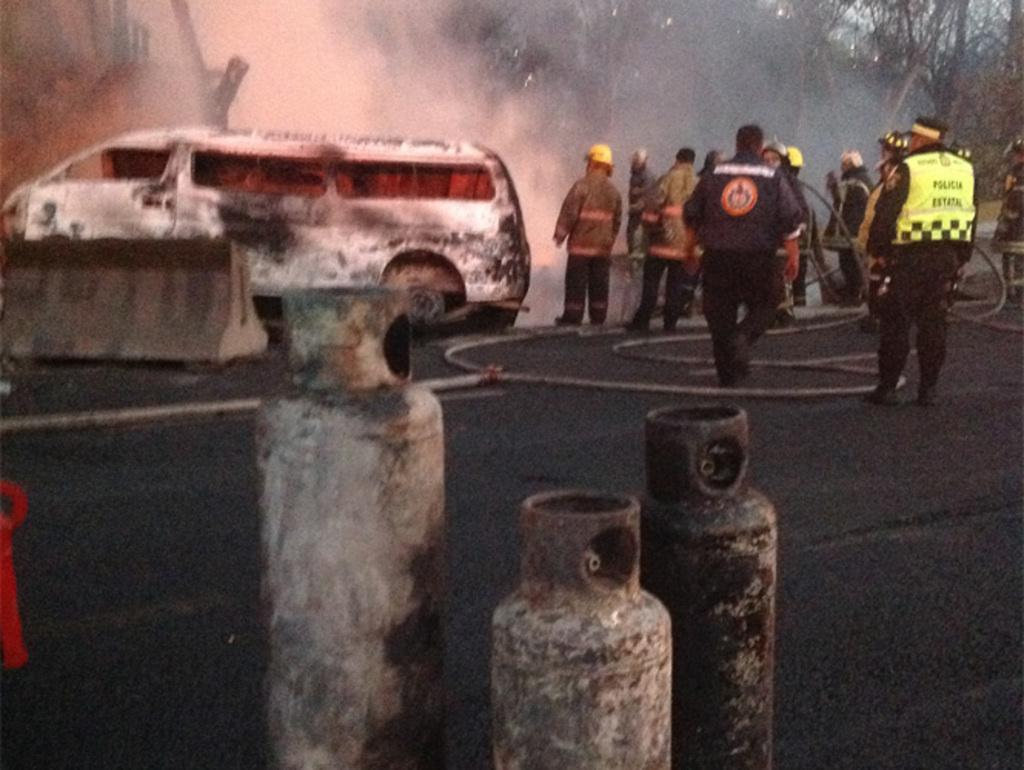What can be seen in the right corner of the image? There are persons standing in the right corner of the image. What is between the persons in the image? There is a pipe between the persons. What type of vehicle is in the left corner of the image? There is a white color vehicle in the left corner of the image. What else is present in the left corner of the image? There is at least one other object in the left corner of the image. What type of mark can be seen on the persons in the image? There is no mention of any marks on the persons in the image. What kind of machine is present in the image? There is no mention of any machine in the image. 